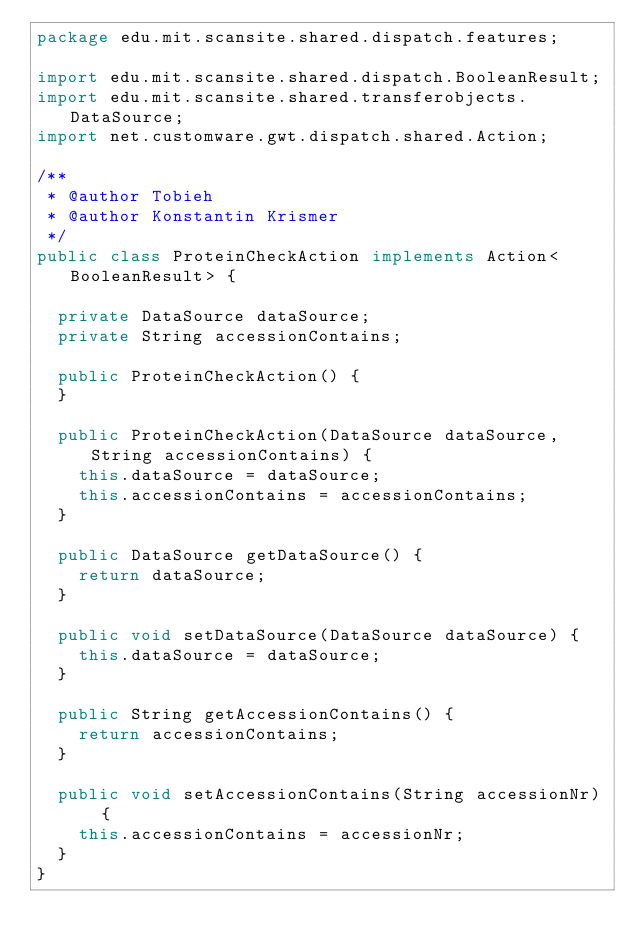Convert code to text. <code><loc_0><loc_0><loc_500><loc_500><_Java_>package edu.mit.scansite.shared.dispatch.features;

import edu.mit.scansite.shared.dispatch.BooleanResult;
import edu.mit.scansite.shared.transferobjects.DataSource;
import net.customware.gwt.dispatch.shared.Action;

/**
 * @author Tobieh
 * @author Konstantin Krismer
 */
public class ProteinCheckAction implements Action<BooleanResult> {

  private DataSource dataSource;
  private String accessionContains;

  public ProteinCheckAction() {
  }

  public ProteinCheckAction(DataSource dataSource, String accessionContains) {
    this.dataSource = dataSource;
    this.accessionContains = accessionContains;
  }

  public DataSource getDataSource() {
    return dataSource;
  }

  public void setDataSource(DataSource dataSource) {
    this.dataSource = dataSource;
  }

  public String getAccessionContains() {
    return accessionContains;
  }

  public void setAccessionContains(String accessionNr) {
    this.accessionContains = accessionNr;
  }
}
</code> 